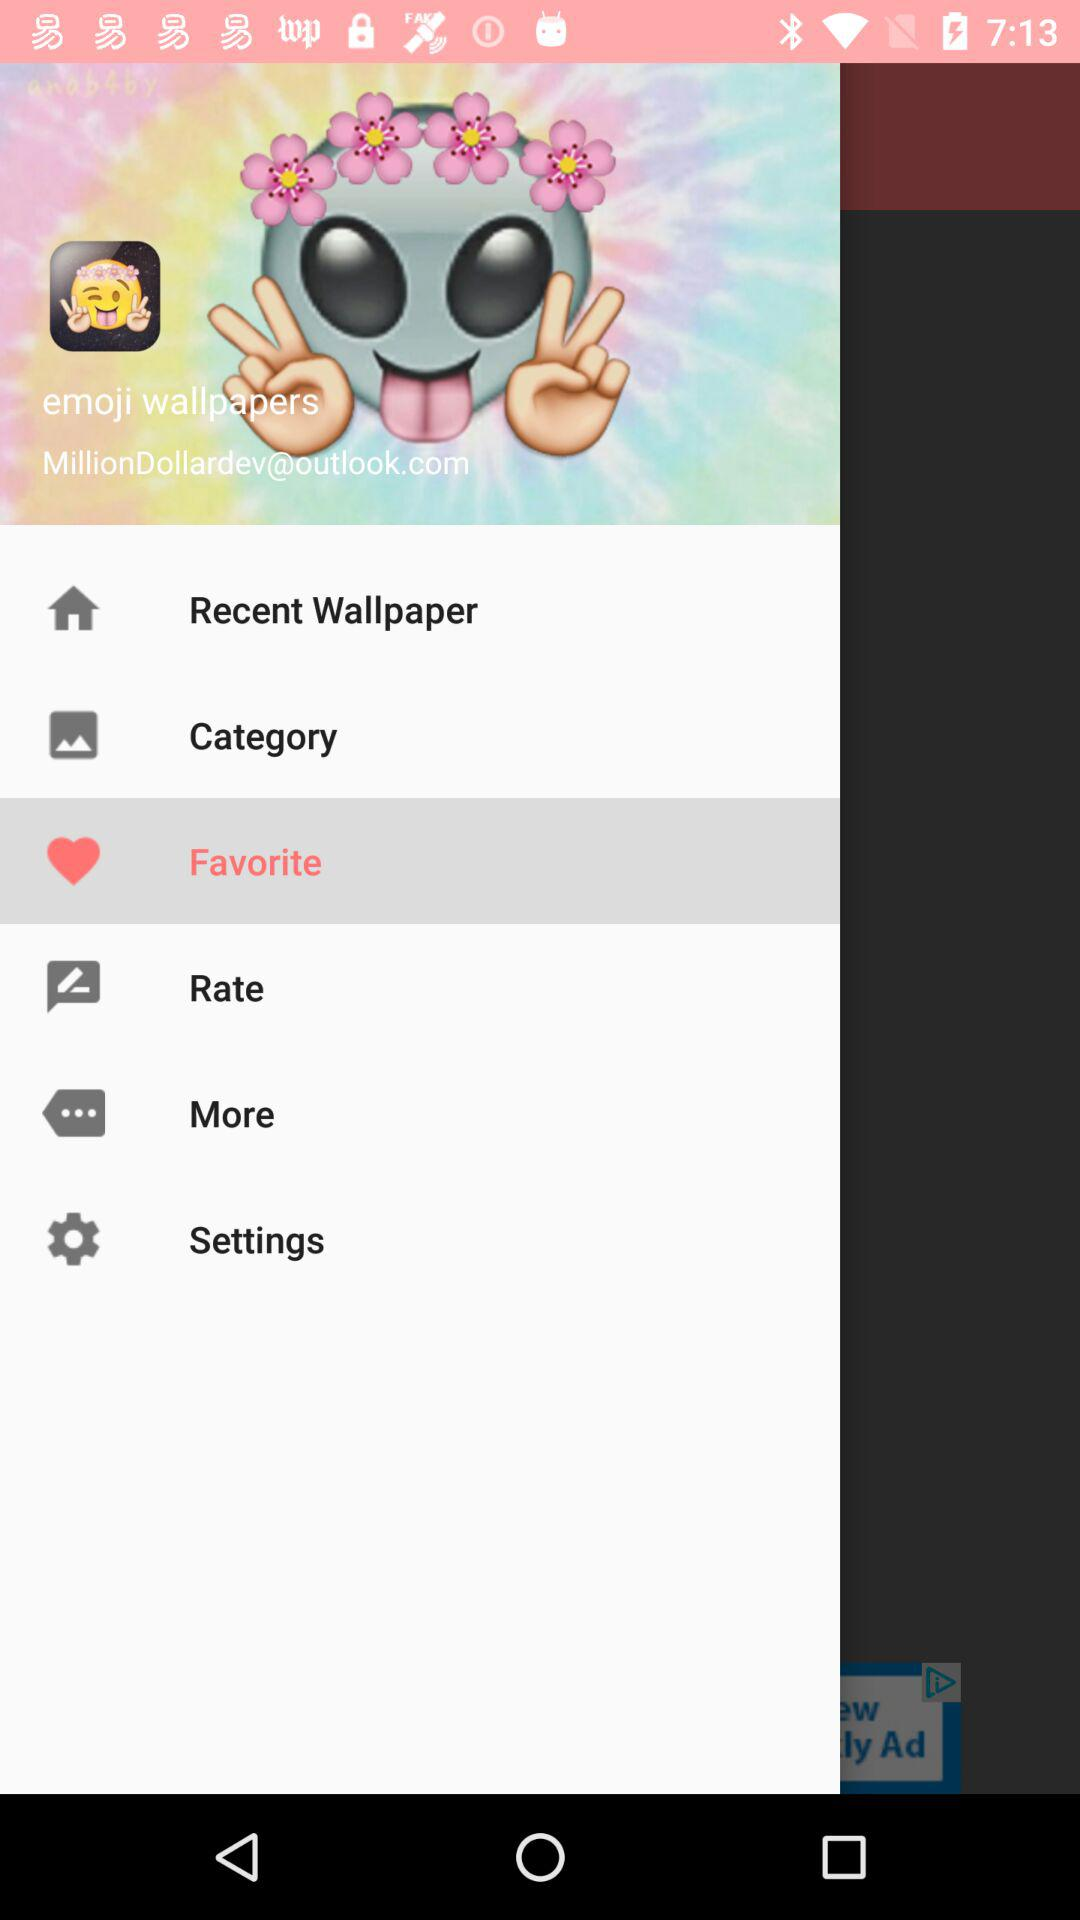What is the application name? The application name is "emoji wallpapers". 